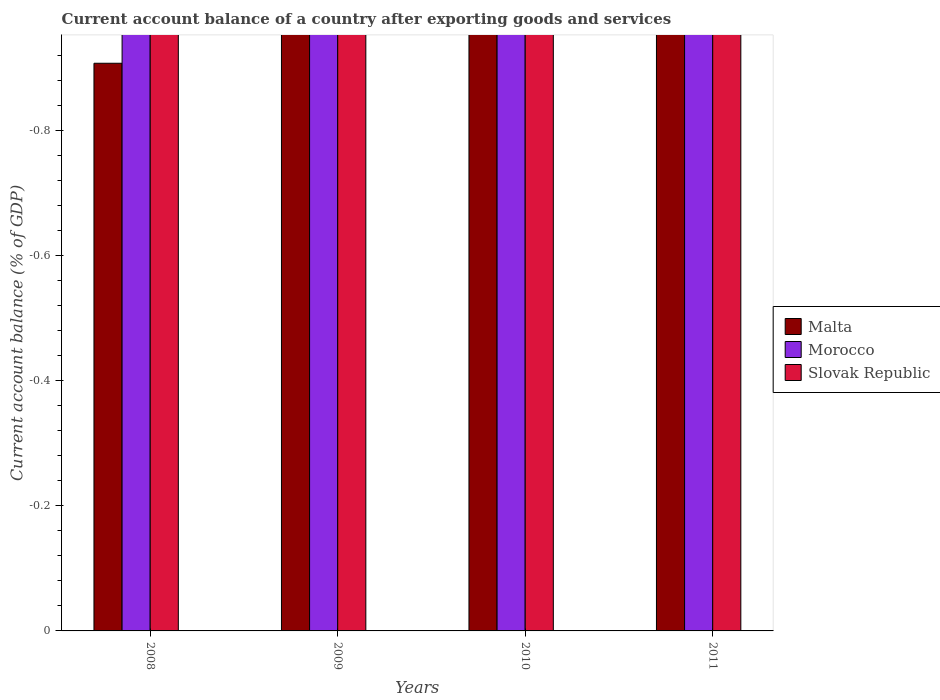Are the number of bars on each tick of the X-axis equal?
Your response must be concise. Yes. How many bars are there on the 4th tick from the left?
Offer a very short reply. 0. How many bars are there on the 1st tick from the right?
Your response must be concise. 0. In how many cases, is the number of bars for a given year not equal to the number of legend labels?
Your response must be concise. 4. What is the difference between the account balance in Slovak Republic in 2011 and the account balance in Malta in 2009?
Provide a succinct answer. 0. In how many years, is the account balance in Morocco greater than the average account balance in Morocco taken over all years?
Your response must be concise. 0. How many bars are there?
Offer a very short reply. 0. How many years are there in the graph?
Your answer should be compact. 4. What is the difference between two consecutive major ticks on the Y-axis?
Make the answer very short. 0.2. What is the title of the graph?
Offer a terse response. Current account balance of a country after exporting goods and services. What is the label or title of the X-axis?
Your answer should be compact. Years. What is the label or title of the Y-axis?
Your answer should be very brief. Current account balance (% of GDP). What is the Current account balance (% of GDP) in Morocco in 2008?
Provide a succinct answer. 0. What is the Current account balance (% of GDP) of Slovak Republic in 2008?
Your answer should be compact. 0. What is the Current account balance (% of GDP) of Malta in 2009?
Offer a very short reply. 0. What is the Current account balance (% of GDP) in Slovak Republic in 2009?
Ensure brevity in your answer.  0. What is the Current account balance (% of GDP) in Malta in 2010?
Make the answer very short. 0. What is the Current account balance (% of GDP) in Malta in 2011?
Your response must be concise. 0. What is the Current account balance (% of GDP) of Morocco in 2011?
Your response must be concise. 0. What is the Current account balance (% of GDP) of Slovak Republic in 2011?
Keep it short and to the point. 0. What is the total Current account balance (% of GDP) in Malta in the graph?
Ensure brevity in your answer.  0. What is the total Current account balance (% of GDP) of Morocco in the graph?
Your response must be concise. 0. What is the average Current account balance (% of GDP) in Morocco per year?
Offer a terse response. 0. 